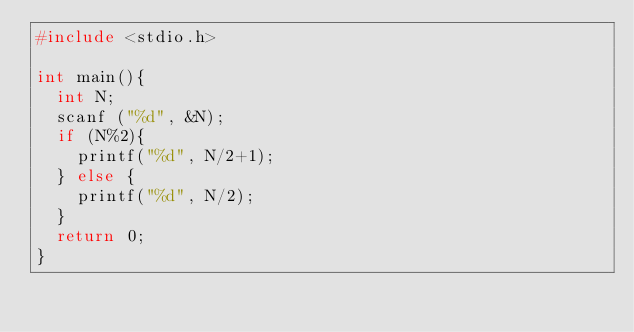Convert code to text. <code><loc_0><loc_0><loc_500><loc_500><_C_>#include <stdio.h>

int main(){
	int N;
	scanf ("%d", &N);
	if (N%2){
		printf("%d", N/2+1);
	} else {
		printf("%d", N/2);
	}
	return 0;
}</code> 